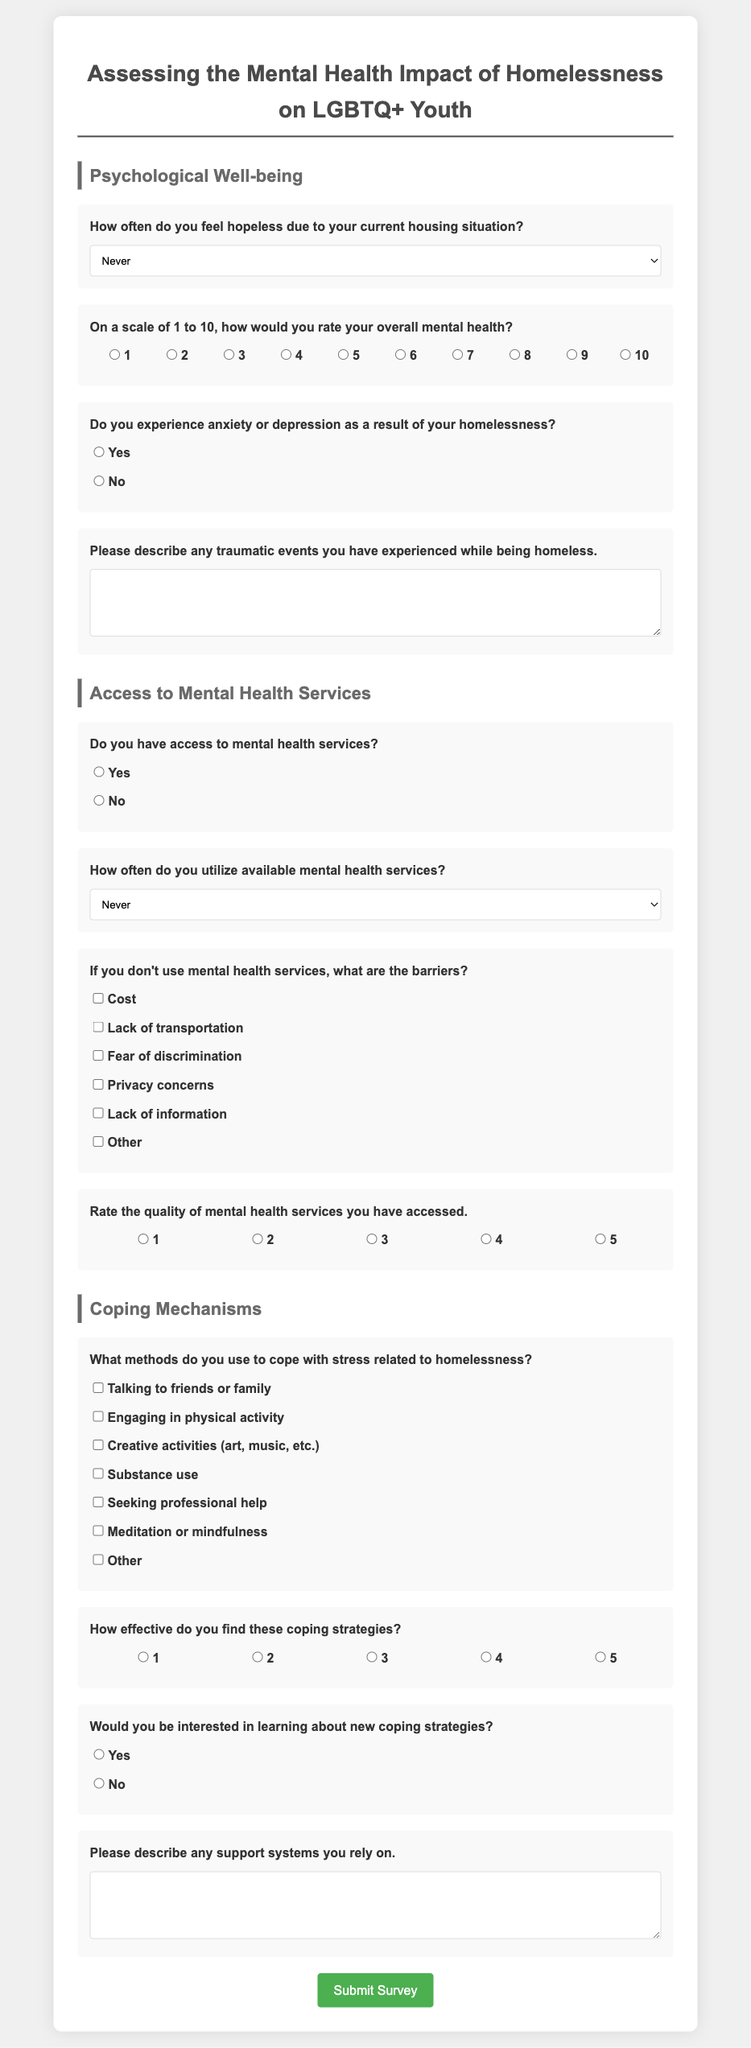What is the title of the survey? The title of the survey is presented at the top of the document as a centered heading.
Answer: Assessing the Mental Health Impact of Homelessness on LGBTQ+ Youth How many sections are in the survey? The document is divided into multiple sections, which are indicated by headings.
Answer: Three What is the first question in the Psychological Well-being section? The first question in the Psychological Well-being section asks about feelings of hopelessness regarding housing.
Answer: How often do you feel hopeless due to your current housing situation? What scale is used for rating overall mental health? The survey utilizes a numeric scale from 1 to 10 for overall mental health rating.
Answer: 1 to 10 What are the potential barriers to accessing mental health services listed? The survey includes options for selecting barriers faced when accessing mental health services.
Answer: Cost, Lack of transportation, Fear of discrimination, Privacy concerns, Lack of information, Other What method of coping is related to physical activity? This question asks about coping mechanisms that include engaging in physical activities.
Answer: Engaging in physical activity How effective do respondents find their coping strategies? Respondents are asked to rate the effectiveness of their coping strategies on a scale from 1 to 5.
Answer: 1 to 5 What type of response does the survey allow for describing supportive systems? The survey allows for a detailed response, specifically asking for descriptions of support systems.
Answer: Open-ended text Would participants be interested in learning about new coping strategies? One of the questions directly asks respondents if they are interested in new coping strategies.
Answer: Yes or No 